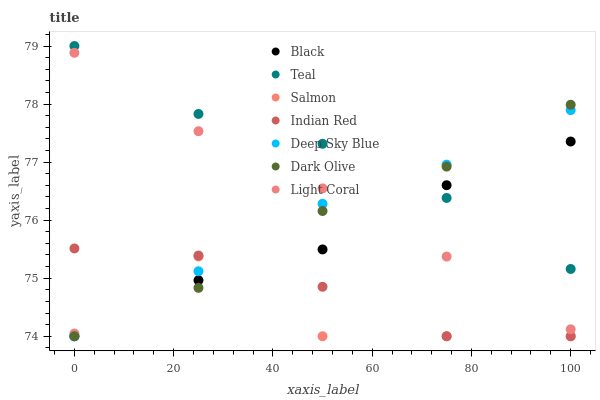Does Salmon have the minimum area under the curve?
Answer yes or no. Yes. Does Teal have the maximum area under the curve?
Answer yes or no. Yes. Does Dark Olive have the minimum area under the curve?
Answer yes or no. No. Does Dark Olive have the maximum area under the curve?
Answer yes or no. No. Is Light Coral the smoothest?
Answer yes or no. Yes. Is Salmon the roughest?
Answer yes or no. Yes. Is Dark Olive the smoothest?
Answer yes or no. No. Is Dark Olive the roughest?
Answer yes or no. No. Does Dark Olive have the lowest value?
Answer yes or no. Yes. Does Light Coral have the lowest value?
Answer yes or no. No. Does Teal have the highest value?
Answer yes or no. Yes. Does Dark Olive have the highest value?
Answer yes or no. No. Is Salmon less than Light Coral?
Answer yes or no. Yes. Is Deep Sky Blue greater than Black?
Answer yes or no. Yes. Does Deep Sky Blue intersect Light Coral?
Answer yes or no. Yes. Is Deep Sky Blue less than Light Coral?
Answer yes or no. No. Is Deep Sky Blue greater than Light Coral?
Answer yes or no. No. Does Salmon intersect Light Coral?
Answer yes or no. No. 